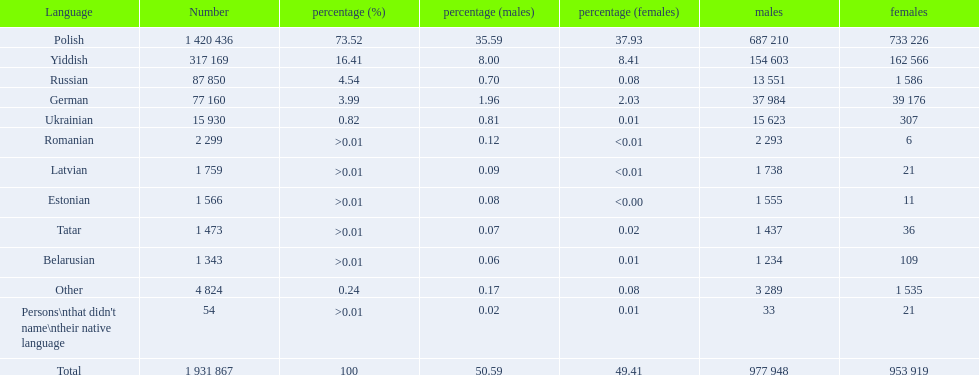What are all of the languages Polish, Yiddish, Russian, German, Ukrainian, Romanian, Latvian, Estonian, Tatar, Belarusian, Other, Persons\nthat didn't name\ntheir native language. What was the percentage of each? 73.52, 16.41, 4.54, 3.99, 0.82, >0.01, >0.01, >0.01, >0.01, >0.01, 0.24, >0.01. Which languages had a >0.01	 percentage? Romanian, Latvian, Estonian, Tatar, Belarusian. And of those, which is listed first? Romanian. 